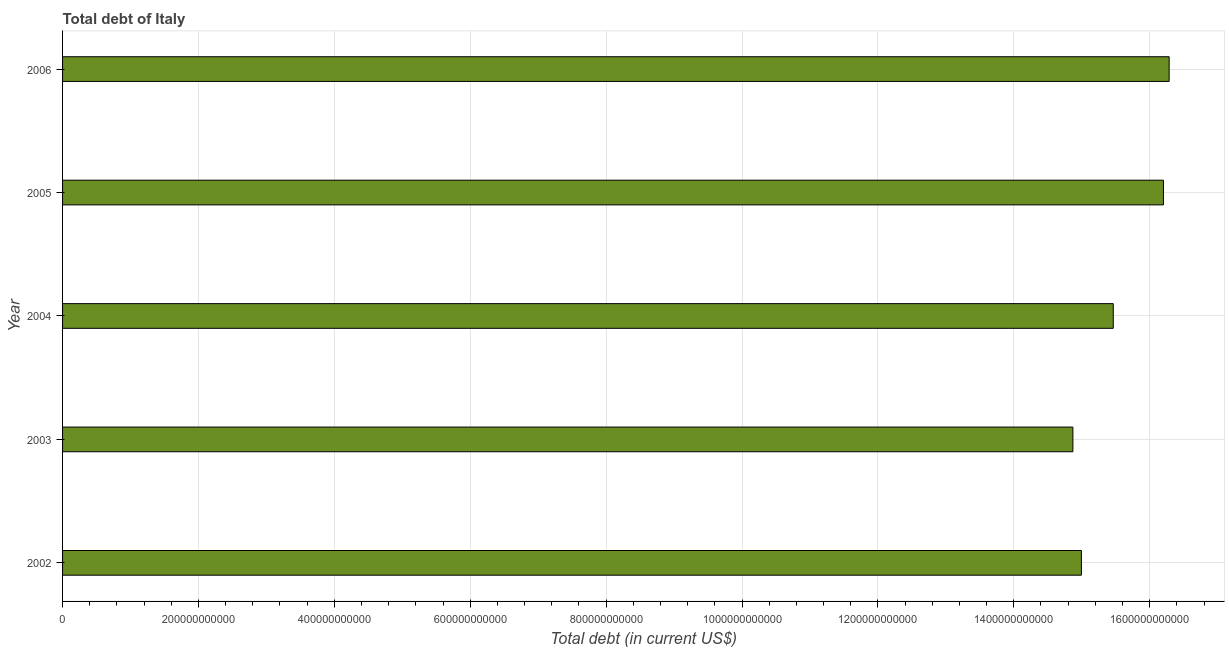Does the graph contain any zero values?
Your response must be concise. No. Does the graph contain grids?
Your answer should be very brief. Yes. What is the title of the graph?
Make the answer very short. Total debt of Italy. What is the label or title of the X-axis?
Your response must be concise. Total debt (in current US$). What is the total debt in 2002?
Provide a short and direct response. 1.50e+12. Across all years, what is the maximum total debt?
Your response must be concise. 1.63e+12. Across all years, what is the minimum total debt?
Offer a very short reply. 1.49e+12. What is the sum of the total debt?
Ensure brevity in your answer.  7.78e+12. What is the difference between the total debt in 2002 and 2006?
Give a very brief answer. -1.29e+11. What is the average total debt per year?
Provide a succinct answer. 1.56e+12. What is the median total debt?
Give a very brief answer. 1.55e+12. What is the ratio of the total debt in 2003 to that in 2005?
Offer a terse response. 0.92. What is the difference between the highest and the second highest total debt?
Make the answer very short. 8.43e+09. Is the sum of the total debt in 2004 and 2006 greater than the maximum total debt across all years?
Your response must be concise. Yes. What is the difference between the highest and the lowest total debt?
Provide a succinct answer. 1.42e+11. Are all the bars in the graph horizontal?
Ensure brevity in your answer.  Yes. How many years are there in the graph?
Your response must be concise. 5. What is the difference between two consecutive major ticks on the X-axis?
Offer a terse response. 2.00e+11. What is the Total debt (in current US$) in 2002?
Give a very brief answer. 1.50e+12. What is the Total debt (in current US$) in 2003?
Your answer should be very brief. 1.49e+12. What is the Total debt (in current US$) of 2004?
Provide a short and direct response. 1.55e+12. What is the Total debt (in current US$) of 2005?
Offer a terse response. 1.62e+12. What is the Total debt (in current US$) in 2006?
Offer a terse response. 1.63e+12. What is the difference between the Total debt (in current US$) in 2002 and 2003?
Make the answer very short. 1.25e+1. What is the difference between the Total debt (in current US$) in 2002 and 2004?
Your response must be concise. -4.69e+1. What is the difference between the Total debt (in current US$) in 2002 and 2005?
Keep it short and to the point. -1.21e+11. What is the difference between the Total debt (in current US$) in 2002 and 2006?
Provide a succinct answer. -1.29e+11. What is the difference between the Total debt (in current US$) in 2003 and 2004?
Provide a short and direct response. -5.94e+1. What is the difference between the Total debt (in current US$) in 2003 and 2005?
Provide a succinct answer. -1.33e+11. What is the difference between the Total debt (in current US$) in 2003 and 2006?
Give a very brief answer. -1.42e+11. What is the difference between the Total debt (in current US$) in 2004 and 2005?
Make the answer very short. -7.38e+1. What is the difference between the Total debt (in current US$) in 2004 and 2006?
Your response must be concise. -8.23e+1. What is the difference between the Total debt (in current US$) in 2005 and 2006?
Offer a terse response. -8.43e+09. What is the ratio of the Total debt (in current US$) in 2002 to that in 2003?
Provide a short and direct response. 1.01. What is the ratio of the Total debt (in current US$) in 2002 to that in 2005?
Your answer should be very brief. 0.93. What is the ratio of the Total debt (in current US$) in 2002 to that in 2006?
Make the answer very short. 0.92. What is the ratio of the Total debt (in current US$) in 2003 to that in 2004?
Give a very brief answer. 0.96. What is the ratio of the Total debt (in current US$) in 2003 to that in 2005?
Provide a succinct answer. 0.92. What is the ratio of the Total debt (in current US$) in 2003 to that in 2006?
Ensure brevity in your answer.  0.91. What is the ratio of the Total debt (in current US$) in 2004 to that in 2005?
Give a very brief answer. 0.95. What is the ratio of the Total debt (in current US$) in 2004 to that in 2006?
Your answer should be very brief. 0.95. What is the ratio of the Total debt (in current US$) in 2005 to that in 2006?
Keep it short and to the point. 0.99. 